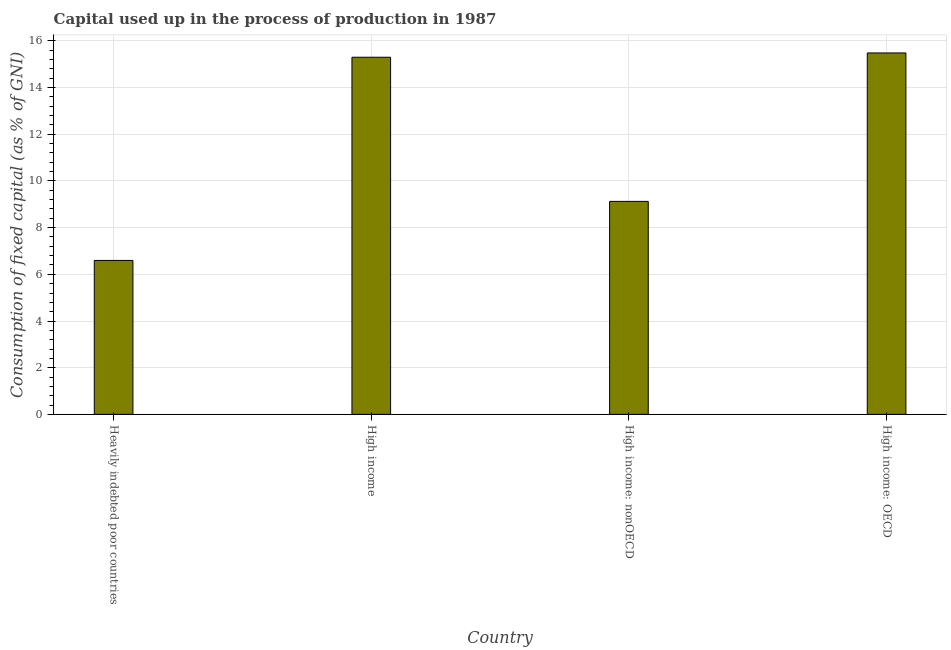Does the graph contain any zero values?
Your answer should be very brief. No. Does the graph contain grids?
Your answer should be compact. Yes. What is the title of the graph?
Offer a very short reply. Capital used up in the process of production in 1987. What is the label or title of the Y-axis?
Offer a terse response. Consumption of fixed capital (as % of GNI). What is the consumption of fixed capital in Heavily indebted poor countries?
Provide a short and direct response. 6.6. Across all countries, what is the maximum consumption of fixed capital?
Provide a succinct answer. 15.48. Across all countries, what is the minimum consumption of fixed capital?
Your answer should be very brief. 6.6. In which country was the consumption of fixed capital maximum?
Your response must be concise. High income: OECD. In which country was the consumption of fixed capital minimum?
Make the answer very short. Heavily indebted poor countries. What is the sum of the consumption of fixed capital?
Make the answer very short. 46.51. What is the difference between the consumption of fixed capital in Heavily indebted poor countries and High income?
Keep it short and to the point. -8.71. What is the average consumption of fixed capital per country?
Ensure brevity in your answer.  11.63. What is the median consumption of fixed capital?
Give a very brief answer. 12.21. In how many countries, is the consumption of fixed capital greater than 9.2 %?
Give a very brief answer. 2. What is the ratio of the consumption of fixed capital in High income to that in High income: nonOECD?
Give a very brief answer. 1.68. Is the consumption of fixed capital in Heavily indebted poor countries less than that in High income: nonOECD?
Your answer should be compact. Yes. Is the difference between the consumption of fixed capital in High income: OECD and High income: nonOECD greater than the difference between any two countries?
Provide a succinct answer. No. What is the difference between the highest and the second highest consumption of fixed capital?
Your response must be concise. 0.18. Is the sum of the consumption of fixed capital in Heavily indebted poor countries and High income: OECD greater than the maximum consumption of fixed capital across all countries?
Your response must be concise. Yes. What is the difference between the highest and the lowest consumption of fixed capital?
Your response must be concise. 8.89. In how many countries, is the consumption of fixed capital greater than the average consumption of fixed capital taken over all countries?
Keep it short and to the point. 2. How many bars are there?
Give a very brief answer. 4. How many countries are there in the graph?
Give a very brief answer. 4. What is the difference between two consecutive major ticks on the Y-axis?
Keep it short and to the point. 2. What is the Consumption of fixed capital (as % of GNI) in Heavily indebted poor countries?
Offer a very short reply. 6.6. What is the Consumption of fixed capital (as % of GNI) in High income?
Provide a short and direct response. 15.3. What is the Consumption of fixed capital (as % of GNI) of High income: nonOECD?
Offer a very short reply. 9.13. What is the Consumption of fixed capital (as % of GNI) in High income: OECD?
Your answer should be compact. 15.48. What is the difference between the Consumption of fixed capital (as % of GNI) in Heavily indebted poor countries and High income?
Offer a very short reply. -8.71. What is the difference between the Consumption of fixed capital (as % of GNI) in Heavily indebted poor countries and High income: nonOECD?
Make the answer very short. -2.53. What is the difference between the Consumption of fixed capital (as % of GNI) in Heavily indebted poor countries and High income: OECD?
Give a very brief answer. -8.89. What is the difference between the Consumption of fixed capital (as % of GNI) in High income and High income: nonOECD?
Your answer should be very brief. 6.18. What is the difference between the Consumption of fixed capital (as % of GNI) in High income and High income: OECD?
Your answer should be compact. -0.18. What is the difference between the Consumption of fixed capital (as % of GNI) in High income: nonOECD and High income: OECD?
Give a very brief answer. -6.36. What is the ratio of the Consumption of fixed capital (as % of GNI) in Heavily indebted poor countries to that in High income?
Make the answer very short. 0.43. What is the ratio of the Consumption of fixed capital (as % of GNI) in Heavily indebted poor countries to that in High income: nonOECD?
Your answer should be very brief. 0.72. What is the ratio of the Consumption of fixed capital (as % of GNI) in Heavily indebted poor countries to that in High income: OECD?
Provide a short and direct response. 0.43. What is the ratio of the Consumption of fixed capital (as % of GNI) in High income to that in High income: nonOECD?
Provide a succinct answer. 1.68. What is the ratio of the Consumption of fixed capital (as % of GNI) in High income to that in High income: OECD?
Provide a succinct answer. 0.99. What is the ratio of the Consumption of fixed capital (as % of GNI) in High income: nonOECD to that in High income: OECD?
Provide a short and direct response. 0.59. 